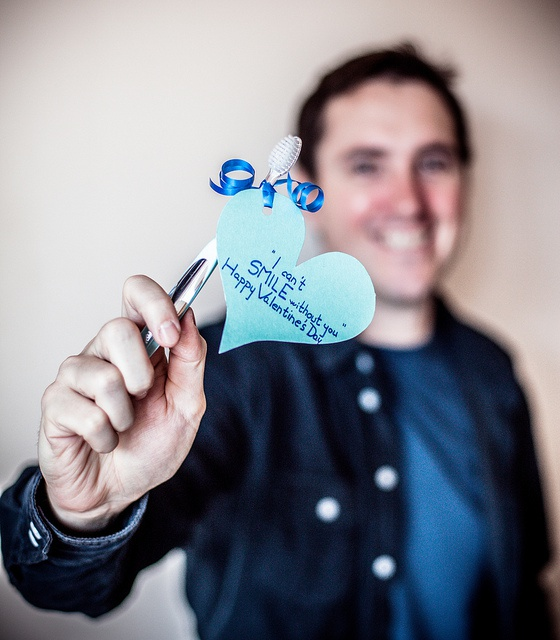Describe the objects in this image and their specific colors. I can see people in gray, black, lightgray, lightpink, and navy tones and toothbrush in gray, lightgray, lightblue, black, and darkgray tones in this image. 